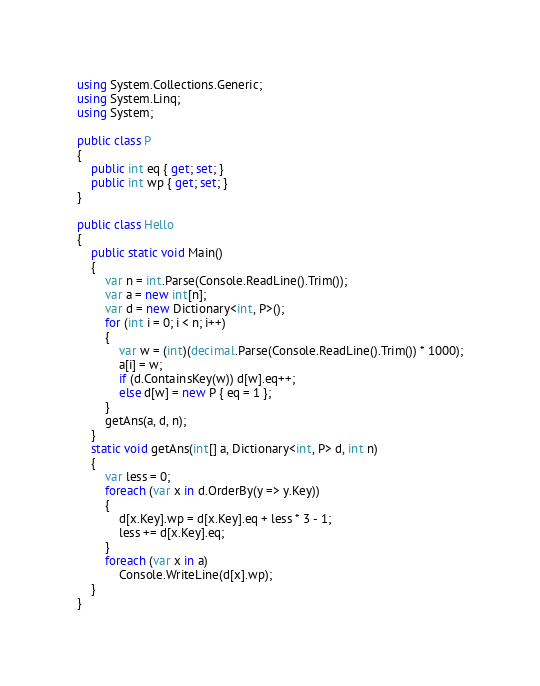<code> <loc_0><loc_0><loc_500><loc_500><_C#_>using System.Collections.Generic;
using System.Linq;
using System;

public class P
{
    public int eq { get; set; }
    public int wp { get; set; }
}

public class Hello
{
    public static void Main()
    {
        var n = int.Parse(Console.ReadLine().Trim());
        var a = new int[n];
        var d = new Dictionary<int, P>();
        for (int i = 0; i < n; i++)
        {
            var w = (int)(decimal.Parse(Console.ReadLine().Trim()) * 1000);
            a[i] = w;
            if (d.ContainsKey(w)) d[w].eq++;
            else d[w] = new P { eq = 1 };
        }
        getAns(a, d, n);
    }
    static void getAns(int[] a, Dictionary<int, P> d, int n)
    {
        var less = 0;
        foreach (var x in d.OrderBy(y => y.Key))
        {
            d[x.Key].wp = d[x.Key].eq + less * 3 - 1;
            less += d[x.Key].eq;
        }
        foreach (var x in a)
            Console.WriteLine(d[x].wp);
    }
}

</code> 